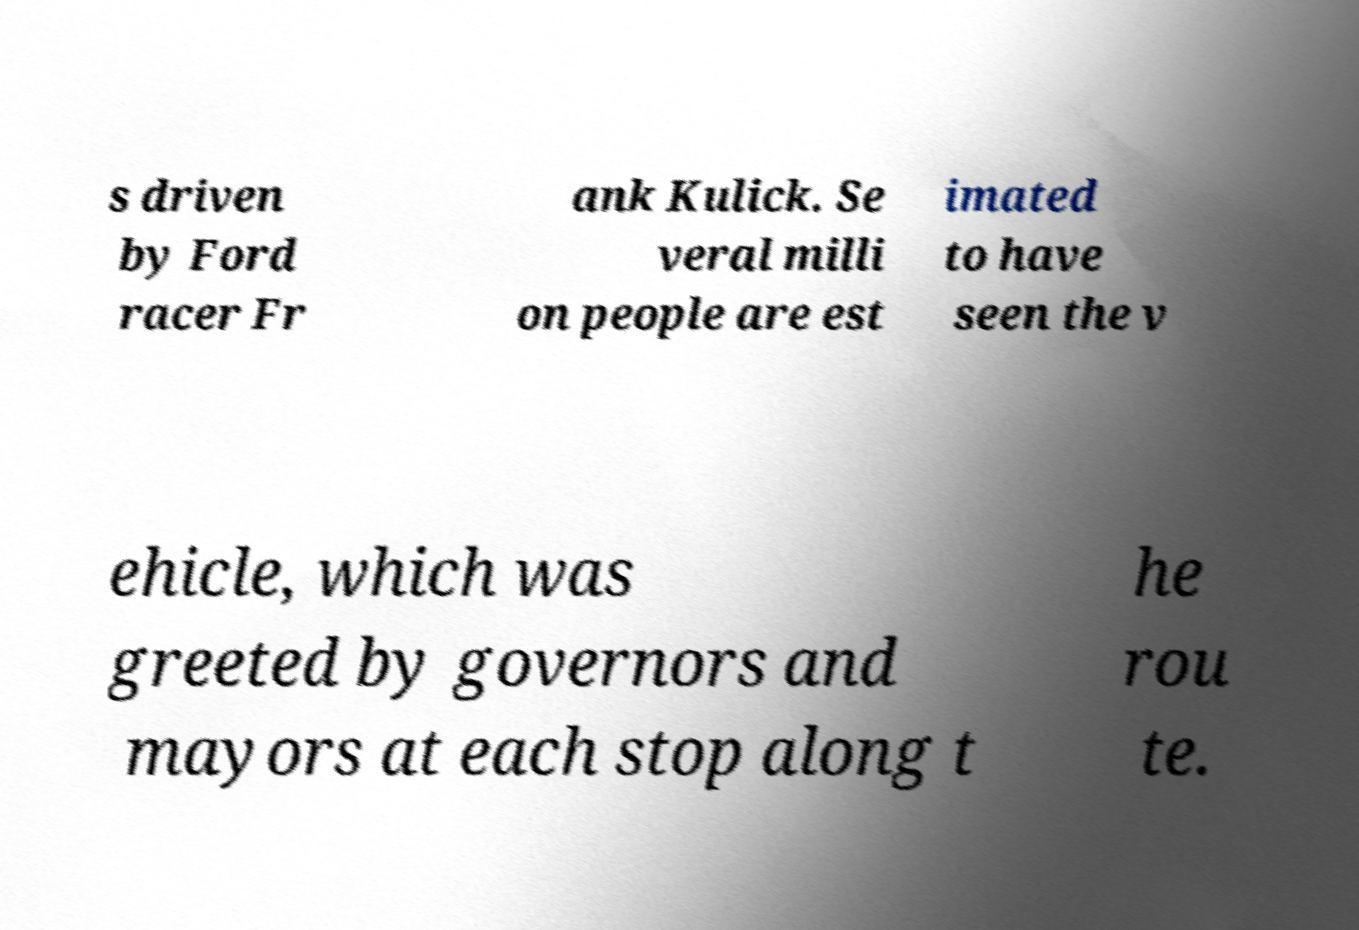Could you extract and type out the text from this image? s driven by Ford racer Fr ank Kulick. Se veral milli on people are est imated to have seen the v ehicle, which was greeted by governors and mayors at each stop along t he rou te. 